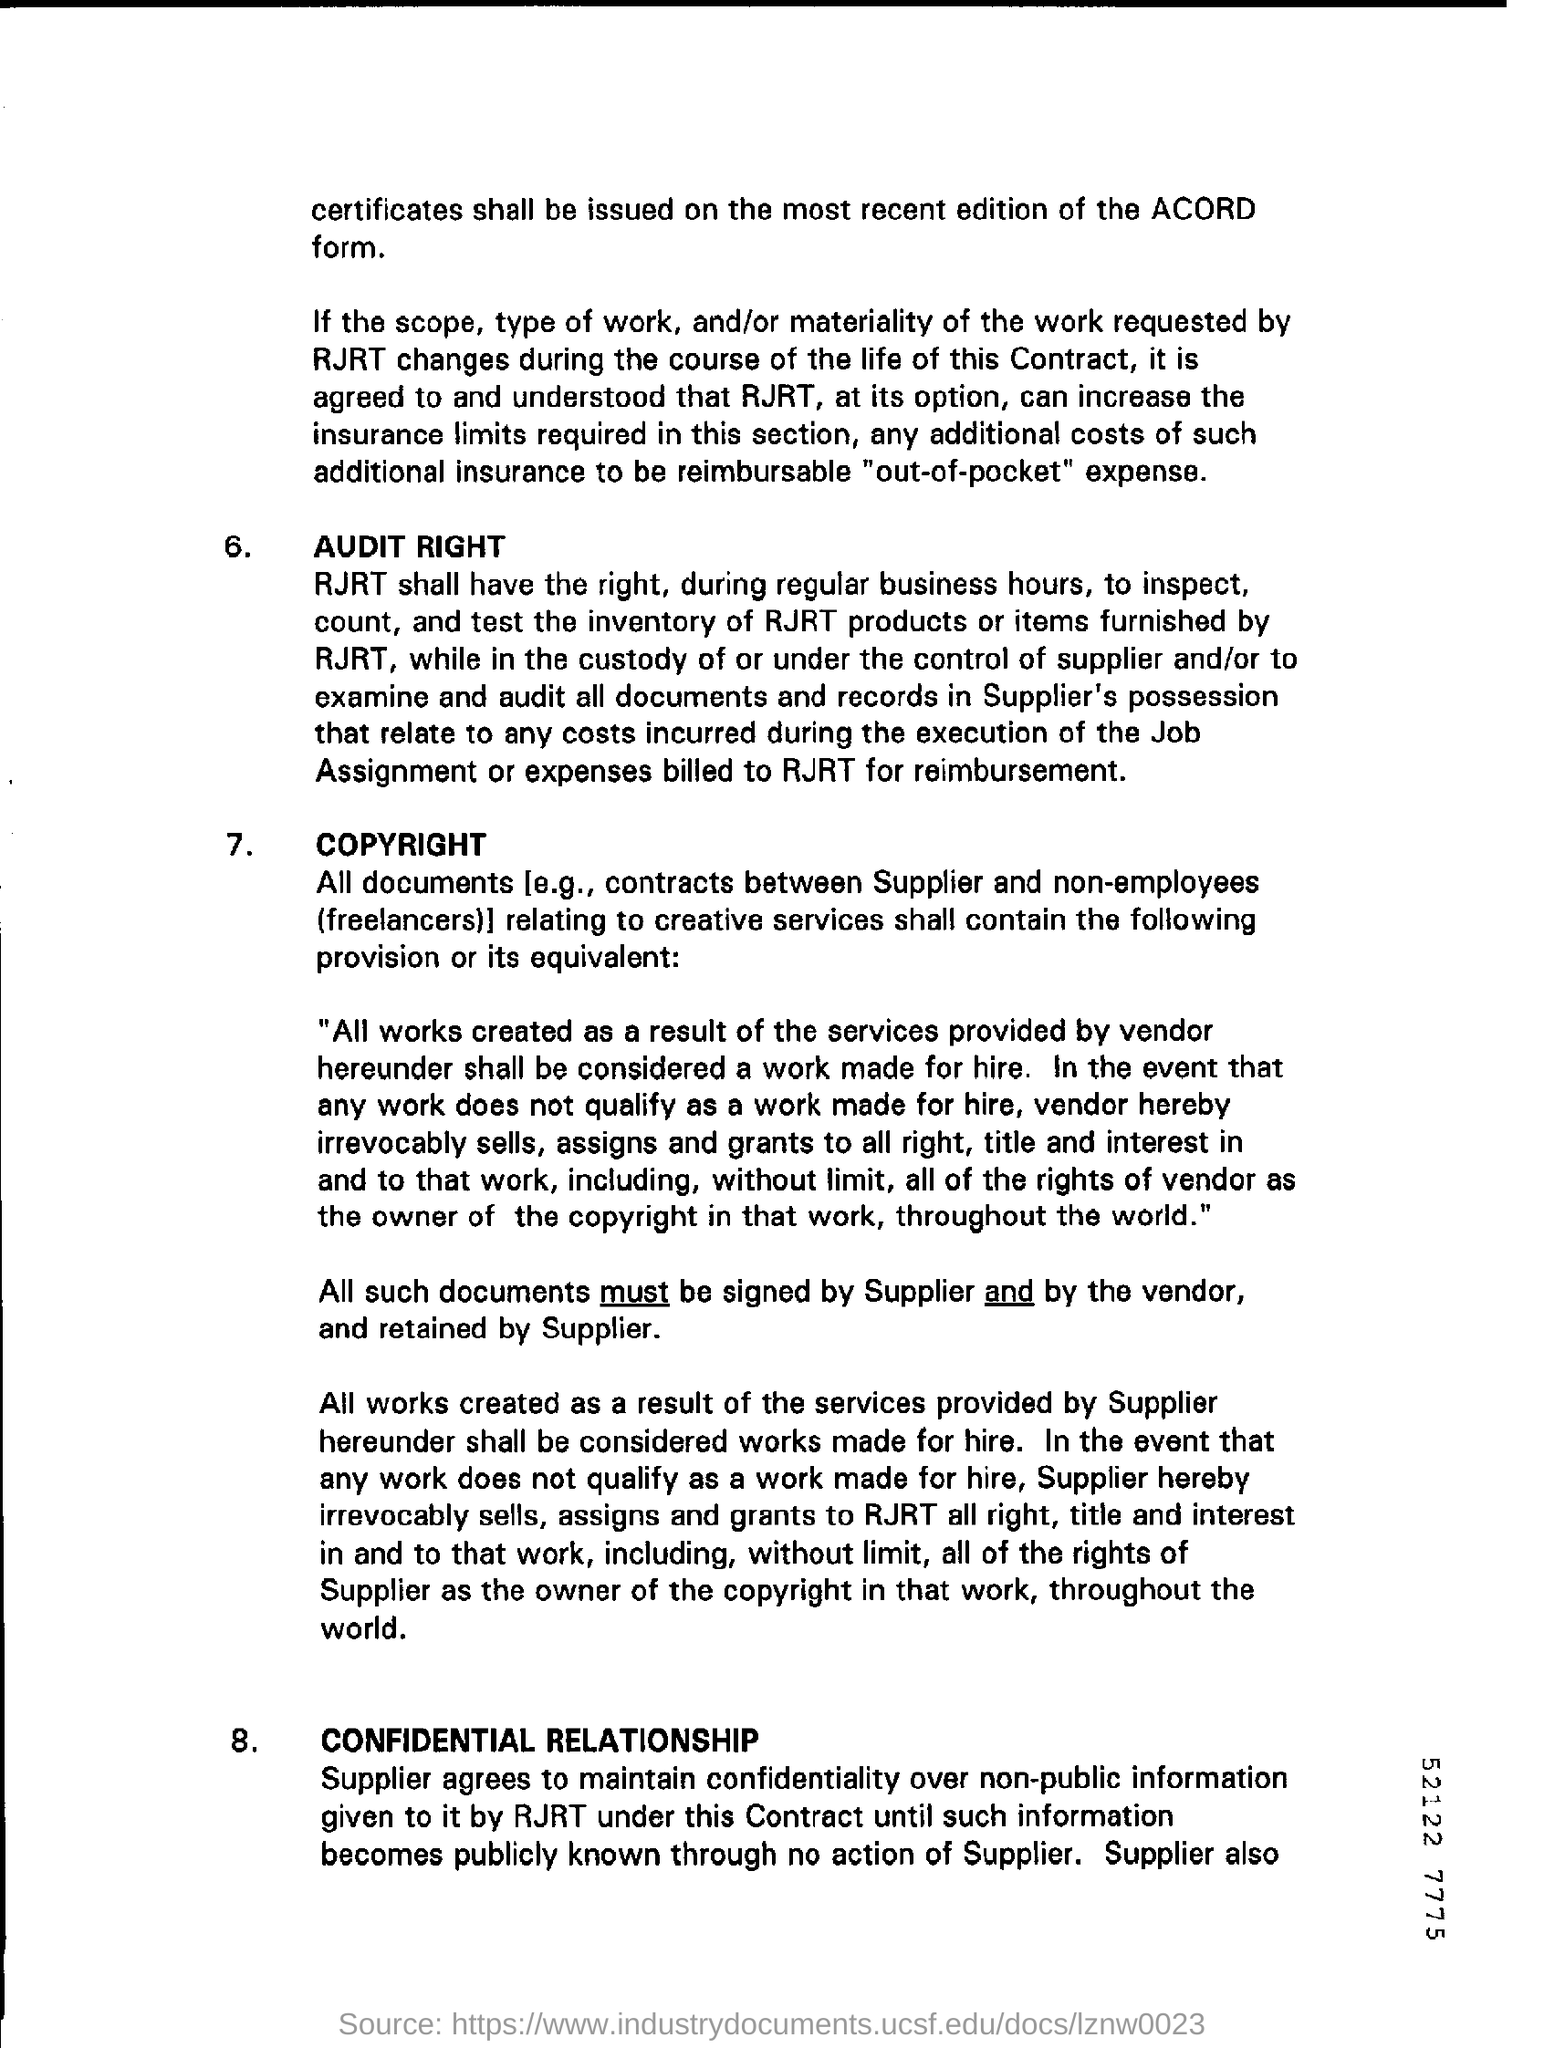Highlight a few significant elements in this photo. The document's first title is 'Audit Right.' 